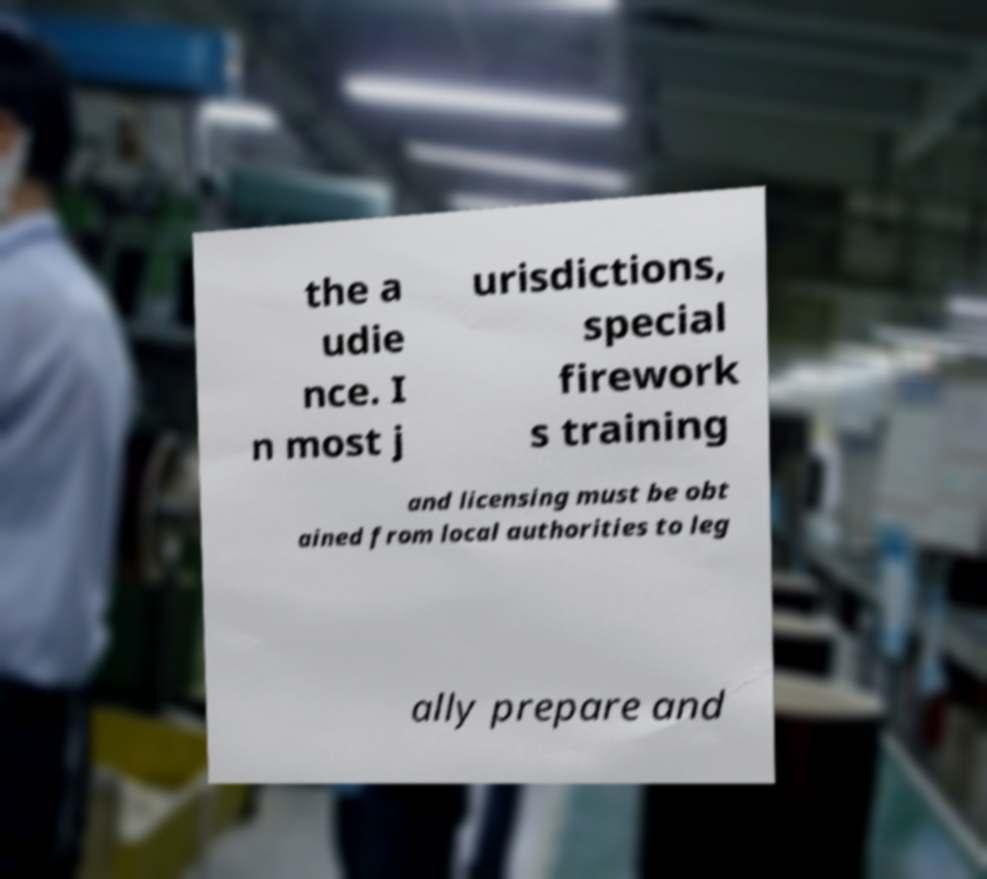For documentation purposes, I need the text within this image transcribed. Could you provide that? the a udie nce. I n most j urisdictions, special firework s training and licensing must be obt ained from local authorities to leg ally prepare and 